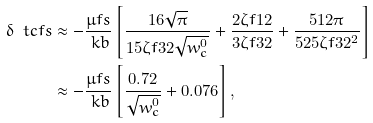Convert formula to latex. <formula><loc_0><loc_0><loc_500><loc_500>\delta \ t c f s & \approx - \frac { \mu f s } { \ k b } \left [ \frac { 1 6 \sqrt { \pi } } { 1 5 \zeta f { 3 } { 2 } \sqrt { w _ { c } ^ { 0 } } } + \frac { 2 \zeta f { 1 } { 2 } } { 3 \zeta f { 3 } { 2 } } + \frac { 5 1 2 \pi } { 5 2 5 \zeta f { 3 } { 2 } ^ { 2 } } \right ] \\ & \approx - \frac { \mu f s } { \ k b } \left [ \frac { 0 . 7 2 } { \sqrt { w _ { c } ^ { 0 } } } + 0 . 0 7 6 \right ] ,</formula> 